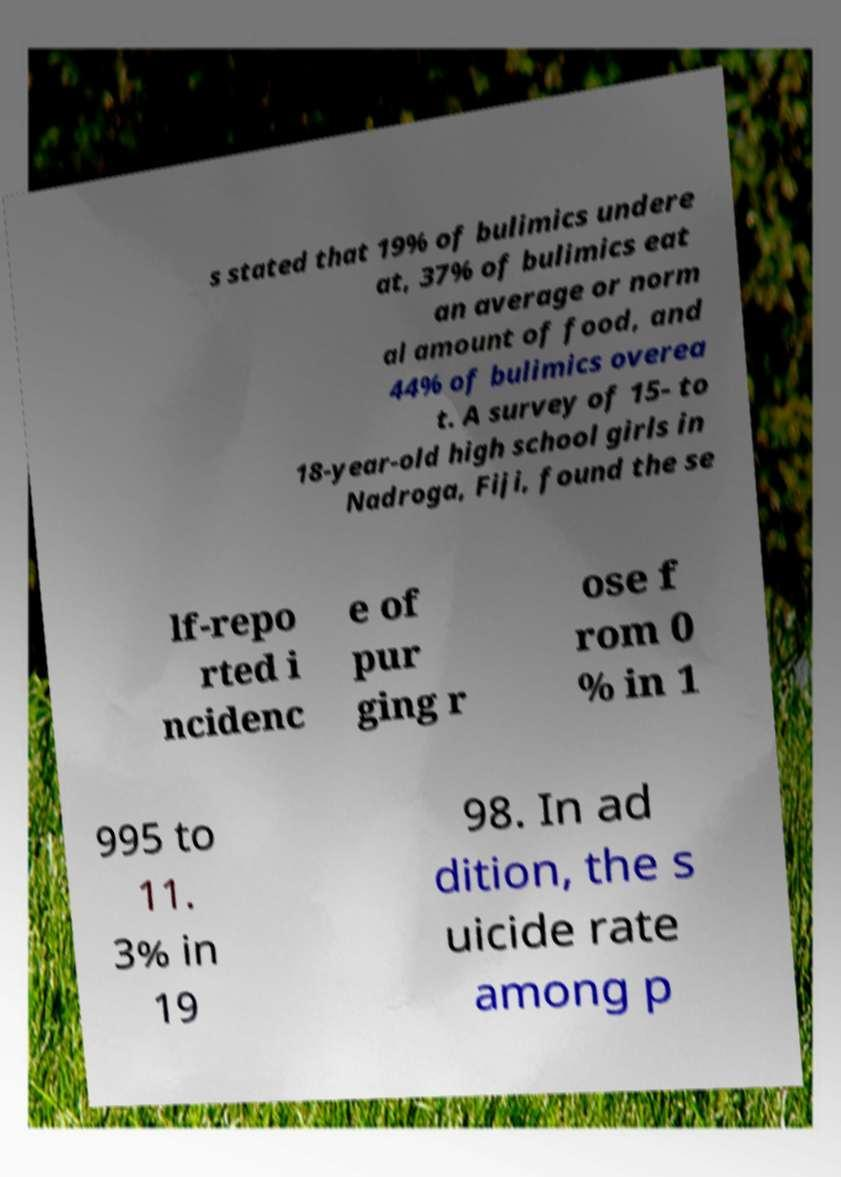I need the written content from this picture converted into text. Can you do that? s stated that 19% of bulimics undere at, 37% of bulimics eat an average or norm al amount of food, and 44% of bulimics overea t. A survey of 15- to 18-year-old high school girls in Nadroga, Fiji, found the se lf-repo rted i ncidenc e of pur ging r ose f rom 0 % in 1 995 to 11. 3% in 19 98. In ad dition, the s uicide rate among p 